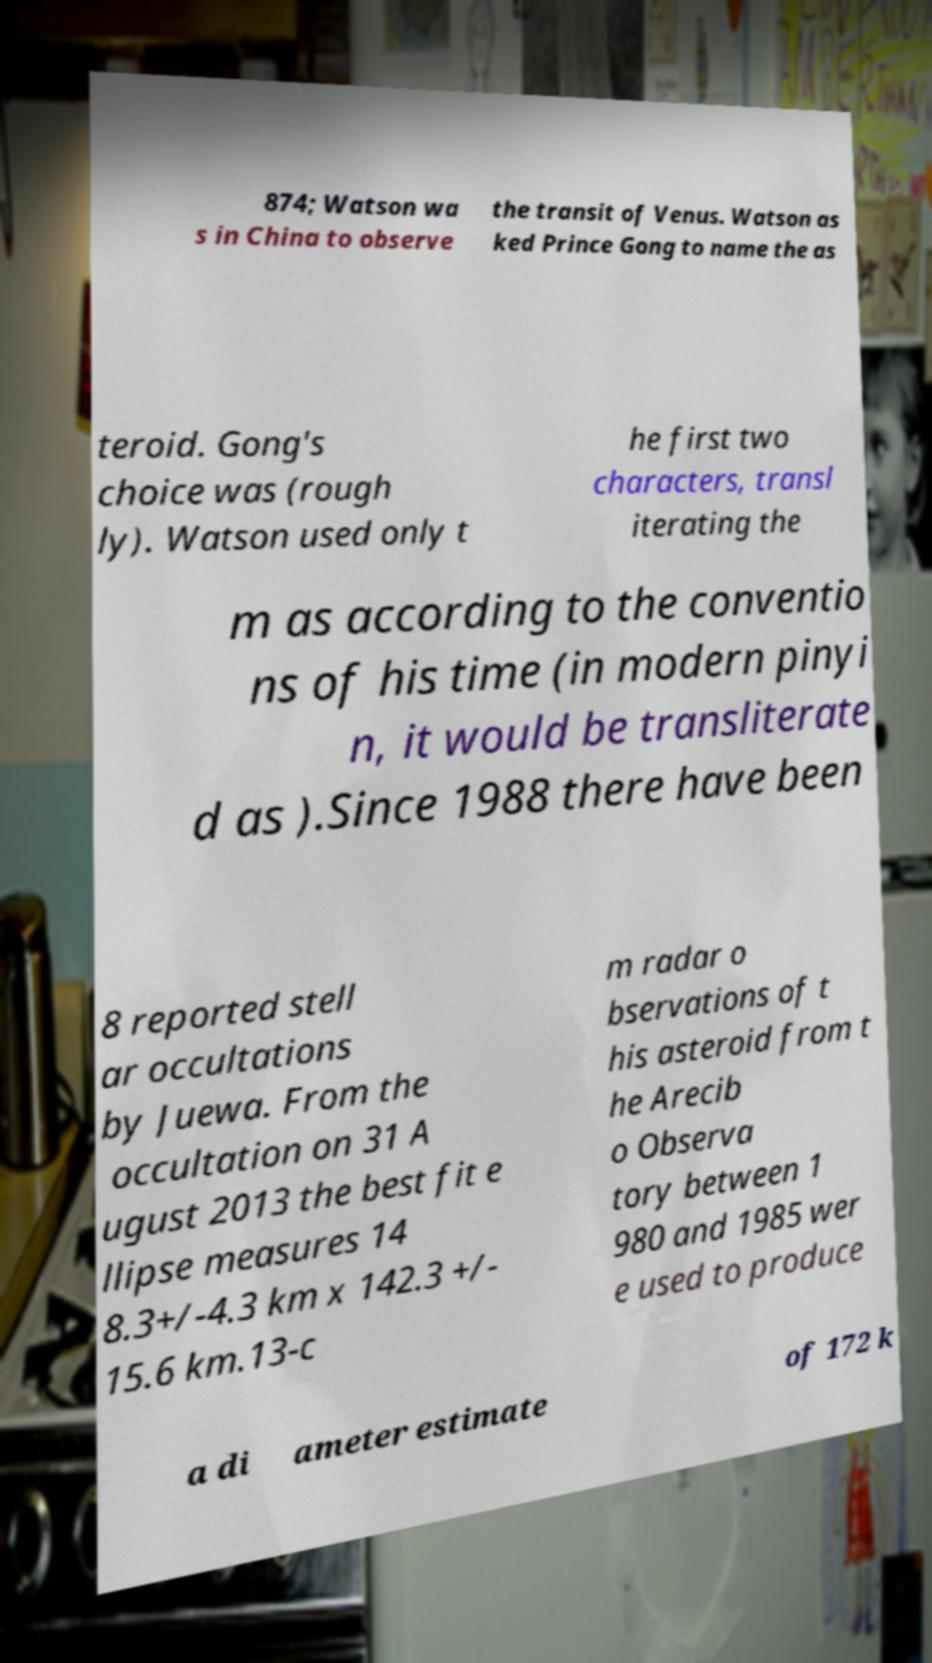Can you read and provide the text displayed in the image?This photo seems to have some interesting text. Can you extract and type it out for me? 874; Watson wa s in China to observe the transit of Venus. Watson as ked Prince Gong to name the as teroid. Gong's choice was (rough ly). Watson used only t he first two characters, transl iterating the m as according to the conventio ns of his time (in modern pinyi n, it would be transliterate d as ).Since 1988 there have been 8 reported stell ar occultations by Juewa. From the occultation on 31 A ugust 2013 the best fit e llipse measures 14 8.3+/-4.3 km x 142.3 +/- 15.6 km.13-c m radar o bservations of t his asteroid from t he Arecib o Observa tory between 1 980 and 1985 wer e used to produce a di ameter estimate of 172 k 